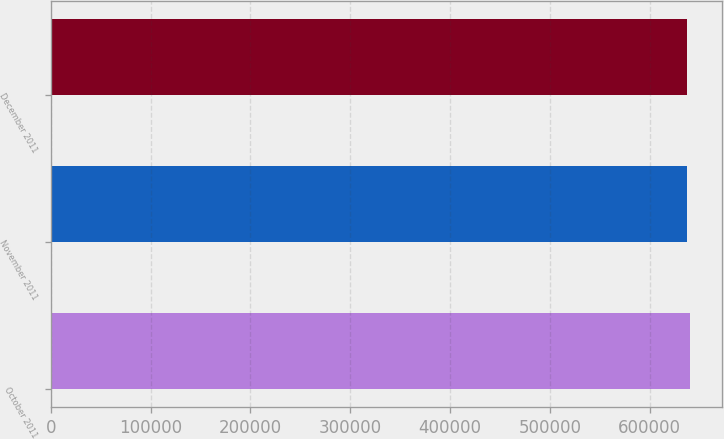Convert chart. <chart><loc_0><loc_0><loc_500><loc_500><bar_chart><fcel>October 2011<fcel>November 2011<fcel>December 2011<nl><fcel>640811<fcel>637532<fcel>637860<nl></chart> 